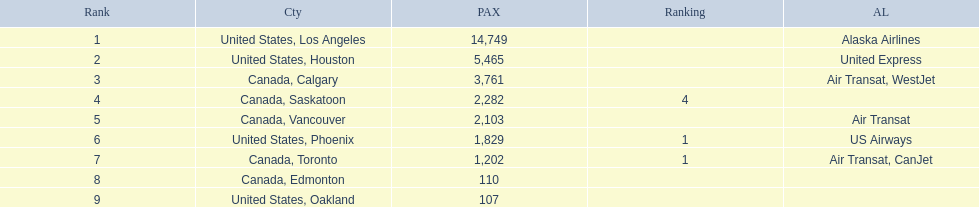Which airport has the least amount of passengers? 107. What airport has 107 passengers? United States, Oakland. 